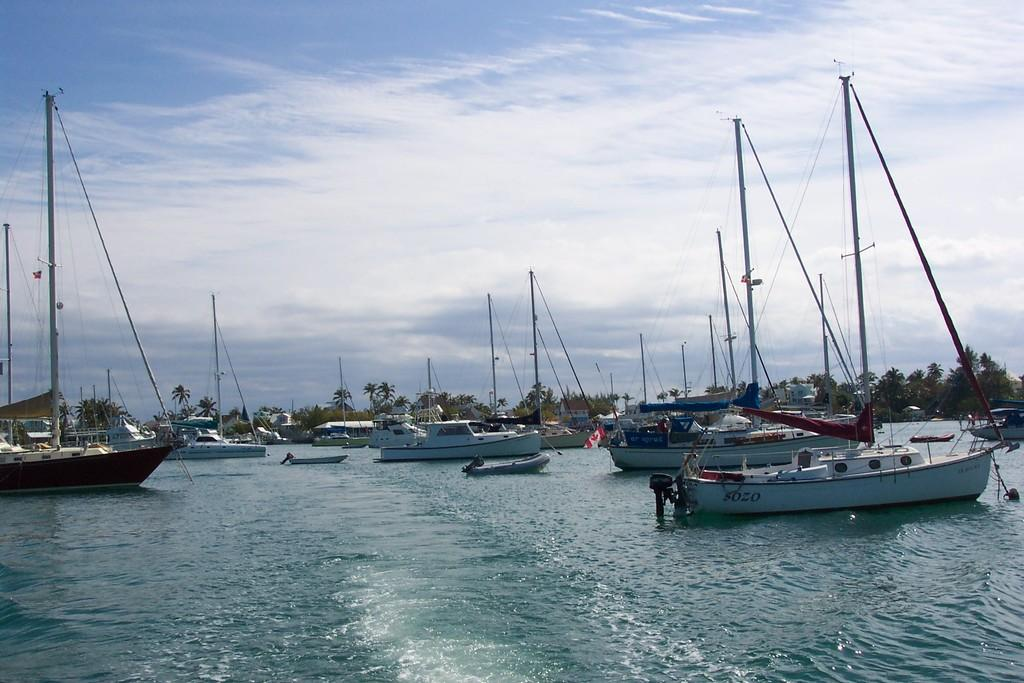What is on the water in the image? There is a fleet on the water in the image. What can be seen in the background of the image? There are trees in the background of the image. What structures are visible in the image? There are poles visible in the image. What is visible above the water and trees in the image? The sky is visible in the image, and there are clouds in the sky. Can you see any fairies flying around the fleet in the image? There are no fairies present in the image. What type of ray is visible in the water near the fleet? There is no ray visible in the water near the fleet in the image. 